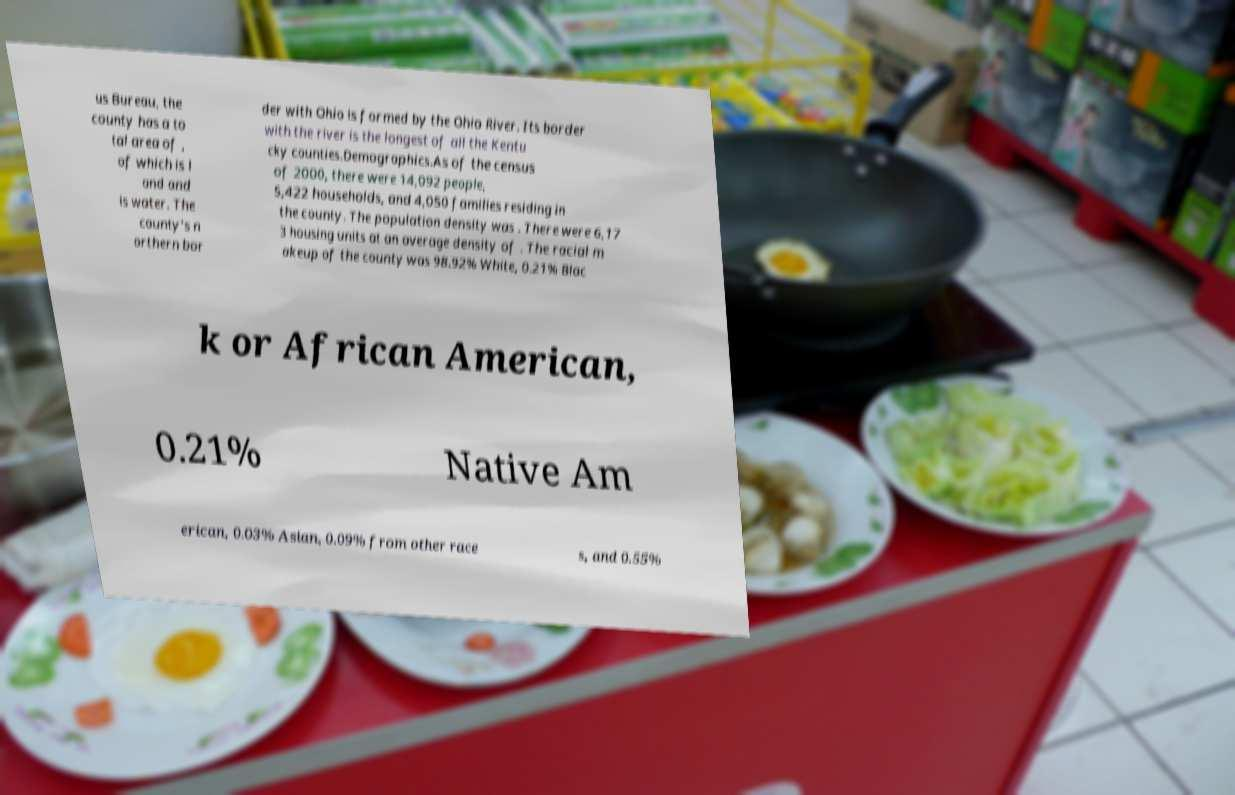For documentation purposes, I need the text within this image transcribed. Could you provide that? us Bureau, the county has a to tal area of , of which is l and and is water. The county's n orthern bor der with Ohio is formed by the Ohio River. Its border with the river is the longest of all the Kentu cky counties.Demographics.As of the census of 2000, there were 14,092 people, 5,422 households, and 4,050 families residing in the county. The population density was . There were 6,17 3 housing units at an average density of . The racial m akeup of the county was 98.92% White, 0.21% Blac k or African American, 0.21% Native Am erican, 0.03% Asian, 0.09% from other race s, and 0.55% 